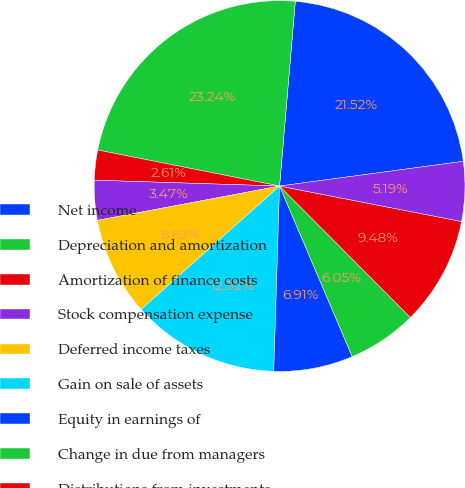Convert chart to OTSL. <chart><loc_0><loc_0><loc_500><loc_500><pie_chart><fcel>Net income<fcel>Depreciation and amortization<fcel>Amortization of finance costs<fcel>Stock compensation expense<fcel>Deferred income taxes<fcel>Gain on sale of assets<fcel>Equity in earnings of<fcel>Change in due from managers<fcel>Distributions from investments<fcel>Changes in other assets<nl><fcel>21.52%<fcel>23.24%<fcel>2.61%<fcel>3.47%<fcel>8.62%<fcel>12.92%<fcel>6.91%<fcel>6.05%<fcel>9.48%<fcel>5.19%<nl></chart> 